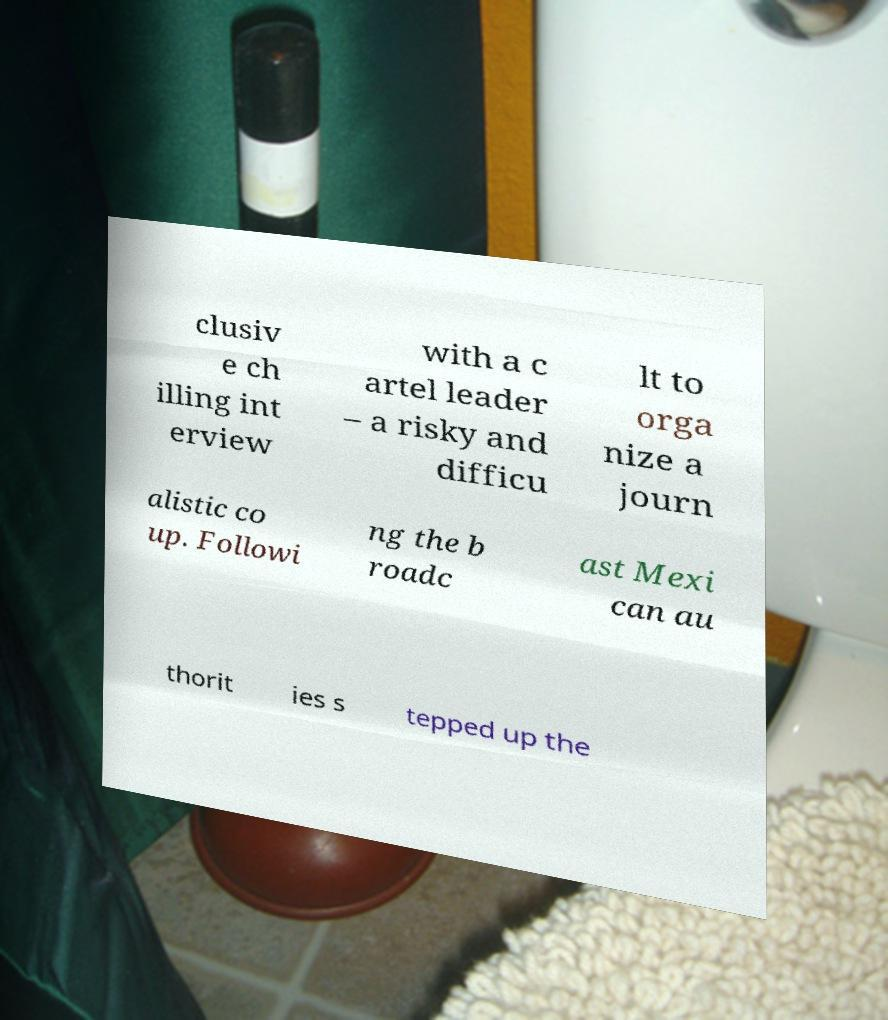Please identify and transcribe the text found in this image. clusiv e ch illing int erview with a c artel leader – a risky and difficu lt to orga nize a journ alistic co up. Followi ng the b roadc ast Mexi can au thorit ies s tepped up the 